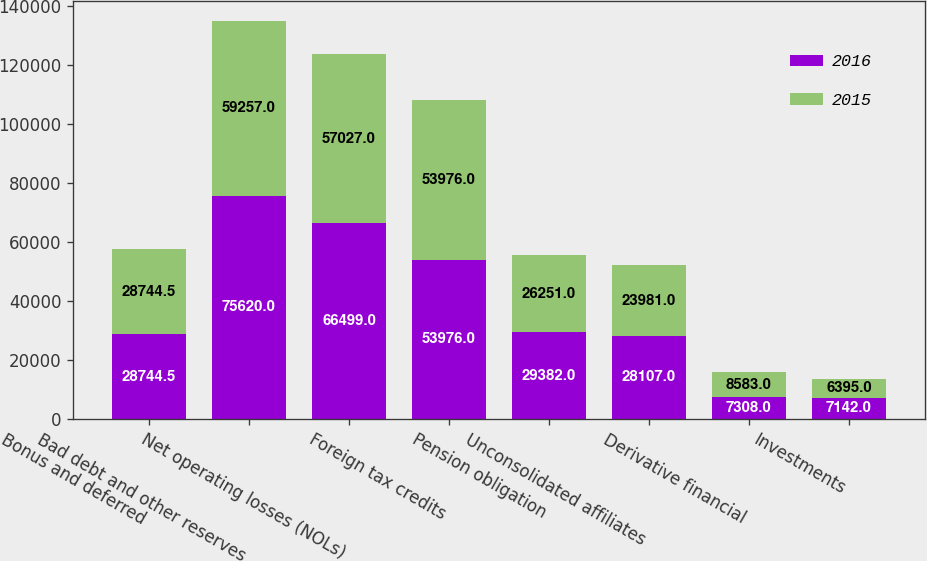<chart> <loc_0><loc_0><loc_500><loc_500><stacked_bar_chart><ecel><fcel>Bonus and deferred<fcel>Bad debt and other reserves<fcel>Net operating losses (NOLs)<fcel>Foreign tax credits<fcel>Pension obligation<fcel>Unconsolidated affiliates<fcel>Derivative financial<fcel>Investments<nl><fcel>2016<fcel>28744.5<fcel>75620<fcel>66499<fcel>53976<fcel>29382<fcel>28107<fcel>7308<fcel>7142<nl><fcel>2015<fcel>28744.5<fcel>59257<fcel>57027<fcel>53976<fcel>26251<fcel>23981<fcel>8583<fcel>6395<nl></chart> 